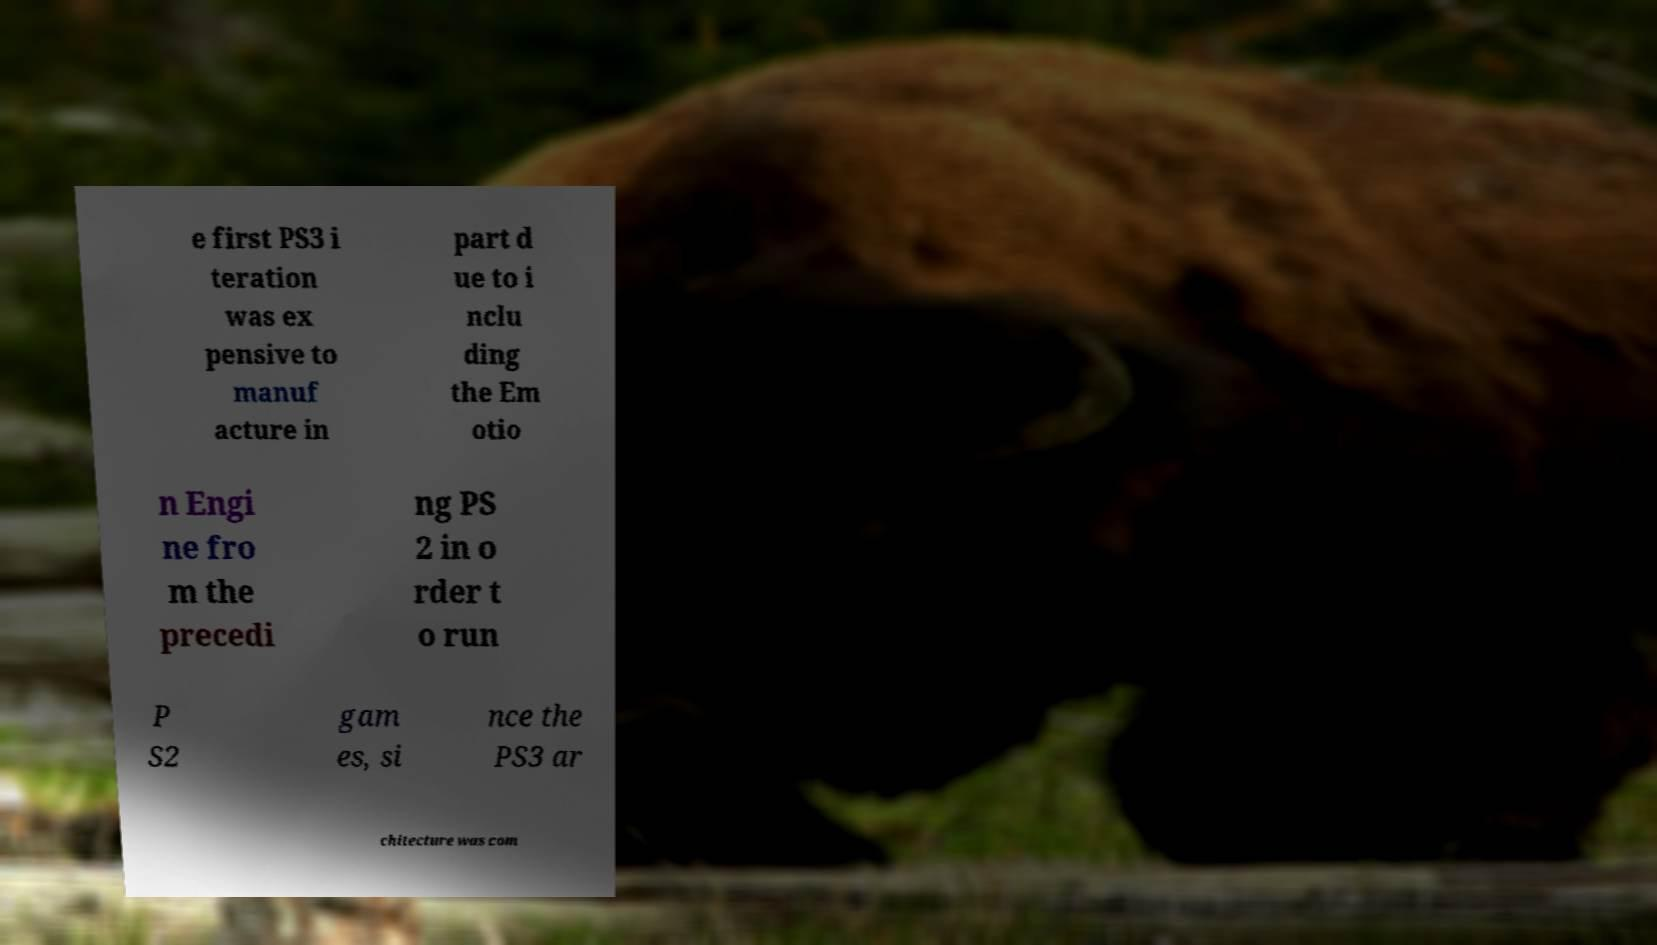I need the written content from this picture converted into text. Can you do that? e first PS3 i teration was ex pensive to manuf acture in part d ue to i nclu ding the Em otio n Engi ne fro m the precedi ng PS 2 in o rder t o run P S2 gam es, si nce the PS3 ar chitecture was com 